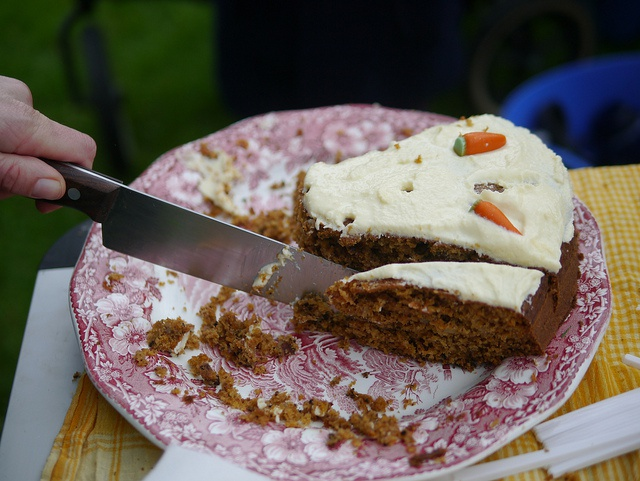Describe the objects in this image and their specific colors. I can see cake in darkgreen, lightgray, maroon, and black tones, dining table in darkgreen, tan, darkgray, gray, and olive tones, knife in darkgreen, gray, black, and maroon tones, chair in darkgreen, navy, black, darkblue, and blue tones, and people in darkgreen, gray, brown, and maroon tones in this image. 